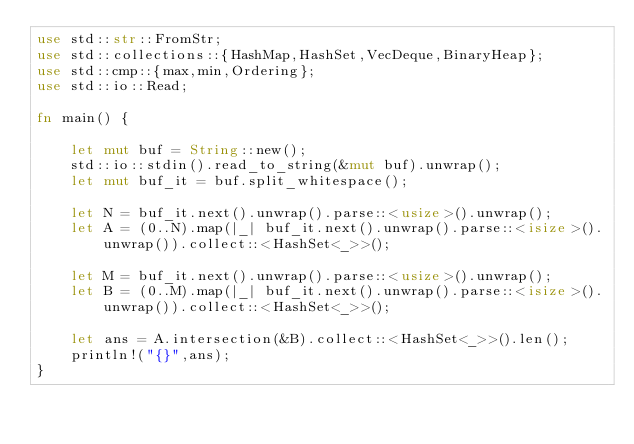Convert code to text. <code><loc_0><loc_0><loc_500><loc_500><_Rust_>use std::str::FromStr;
use std::collections::{HashMap,HashSet,VecDeque,BinaryHeap};
use std::cmp::{max,min,Ordering};
use std::io::Read;

fn main() {

    let mut buf = String::new();
    std::io::stdin().read_to_string(&mut buf).unwrap();
    let mut buf_it = buf.split_whitespace();

    let N = buf_it.next().unwrap().parse::<usize>().unwrap();
    let A = (0..N).map(|_| buf_it.next().unwrap().parse::<isize>().unwrap()).collect::<HashSet<_>>();

    let M = buf_it.next().unwrap().parse::<usize>().unwrap();
    let B = (0..M).map(|_| buf_it.next().unwrap().parse::<isize>().unwrap()).collect::<HashSet<_>>();

    let ans = A.intersection(&B).collect::<HashSet<_>>().len();
    println!("{}",ans);
}
</code> 